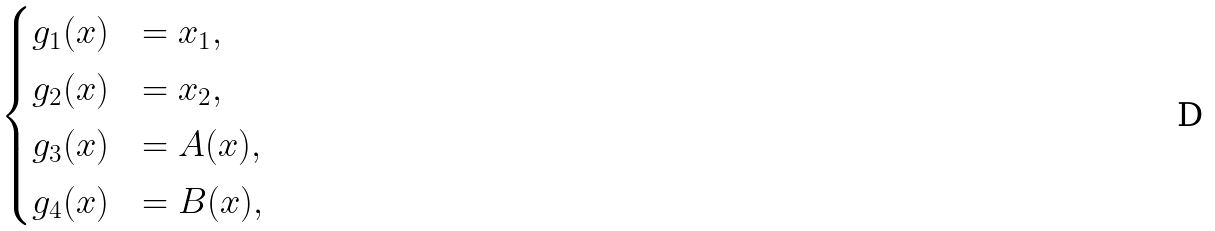Convert formula to latex. <formula><loc_0><loc_0><loc_500><loc_500>\begin{cases} g _ { 1 } ( x ) & = x _ { 1 } , \\ g _ { 2 } ( x ) & = x _ { 2 } , \\ g _ { 3 } ( x ) & = A ( x ) , \\ g _ { 4 } ( x ) & = B ( x ) , \end{cases}</formula> 